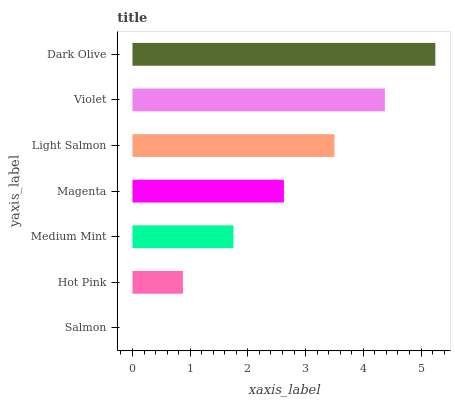Is Salmon the minimum?
Answer yes or no. Yes. Is Dark Olive the maximum?
Answer yes or no. Yes. Is Hot Pink the minimum?
Answer yes or no. No. Is Hot Pink the maximum?
Answer yes or no. No. Is Hot Pink greater than Salmon?
Answer yes or no. Yes. Is Salmon less than Hot Pink?
Answer yes or no. Yes. Is Salmon greater than Hot Pink?
Answer yes or no. No. Is Hot Pink less than Salmon?
Answer yes or no. No. Is Magenta the high median?
Answer yes or no. Yes. Is Magenta the low median?
Answer yes or no. Yes. Is Medium Mint the high median?
Answer yes or no. No. Is Dark Olive the low median?
Answer yes or no. No. 